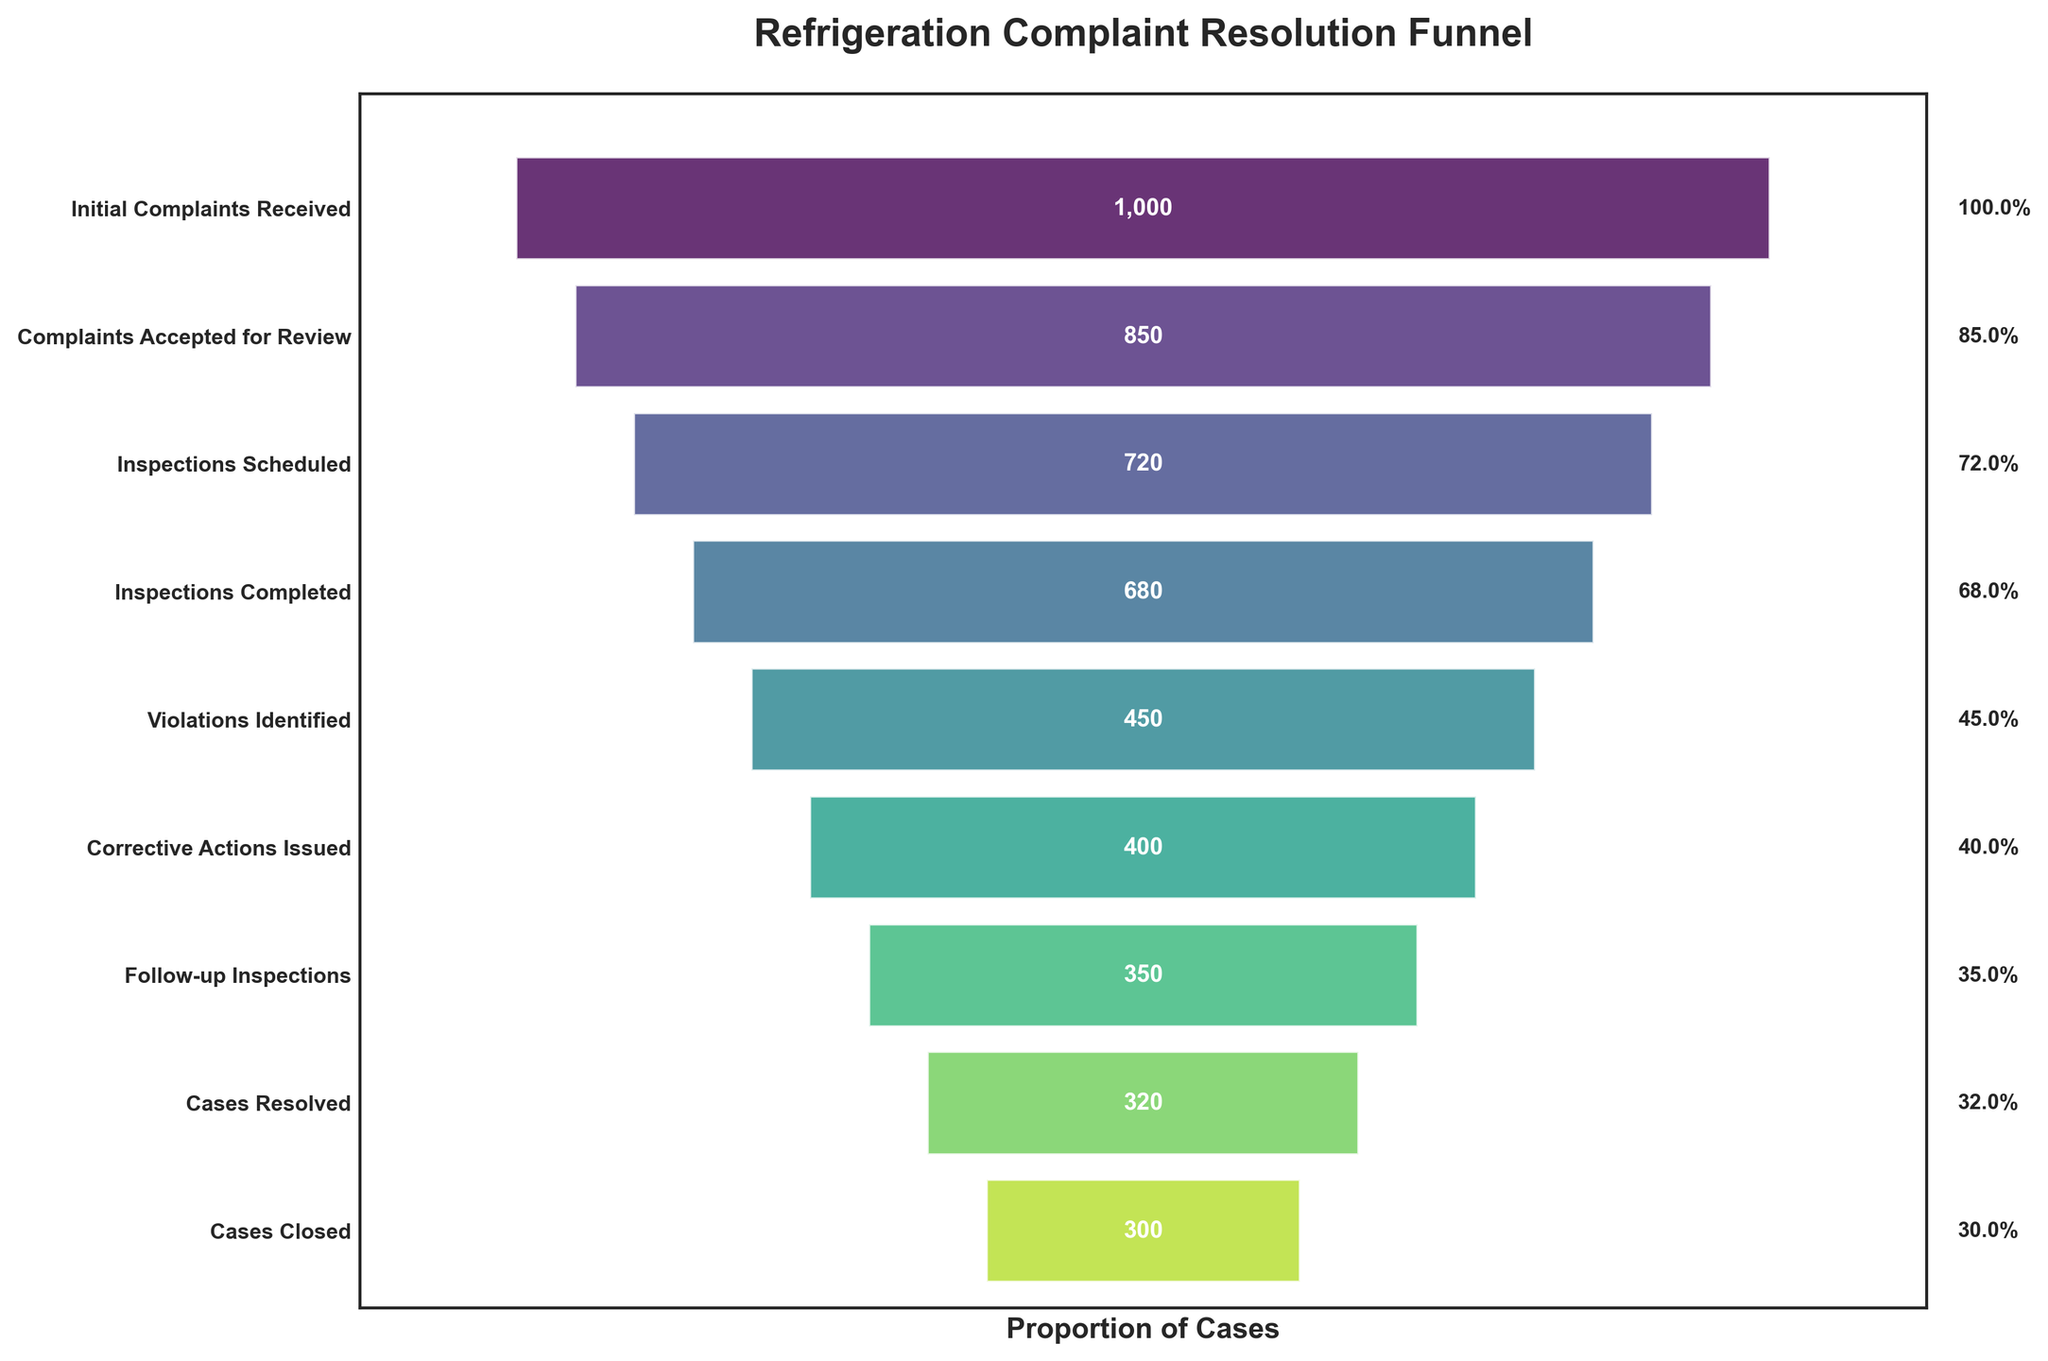What is the title of the chart? The title is usually found at the top of the chart, and it provides a summary of what the chart is about. In this case, it is "Refrigeration Complaint Resolution Funnel" as described in the plotting code.
Answer: Refrigeration Complaint Resolution Funnel How many cases were initially received? Look at the beginning of the funnel where it displays the first stage. The number next to "Initial Complaints Received" is 1000.
Answer: 1000 What percentage of the initial complaints were accepted for review? Divide the "Complaints Accepted for Review" (850) by the "Initial Complaints Received" (1000) and multiply by 100 to get the percentage: (850/1000) * 100 = 85%.
Answer: 85% How many steps are between "Inspections Completed" and "Cases Closed"? Count the number of stages starting from "Inspections Completed" to "Cases Closed." These are "Violations Identified,” "Corrective Actions Issued,” "Follow-up Inspections,” "Cases Resolved,” and "Cases Closed,” making it a total of 5 steps.
Answer: 5 By how much did the number of cases drop from "Violations Identified" to "Corrective Actions Issued"? Subtract the number of "Corrective Actions Issued" (400) from "Violations Identified" (450). The drop is 450 - 400 = 50.
Answer: 50 What stage has the smallest number of cases? Look for the stage with the smallest numeric value listed. This would be the "Cases Closed" stage, which has 300 cases.
Answer: Cases Closed What is the difference in case numbers between the "Follow-up Inspections" and the "Cases Closed" stages? Subtract the number of "Cases Closed" (300) from "Follow-up Inspections" (350). The difference is 350 - 300 = 50.
Answer: 50 What percentage of cases proceeded to follow-up inspections after corrective actions were issued? Divide the "Follow-up Inspections" (350) by the "Corrective Actions Issued" (400) and multiply by 100 to get the percentage: (350/400) * 100 = 87.5%.
Answer: 87.5% How many more cases are resolved than closed? Subtract the number of "Cases Closed" (300) from "Cases Resolved" (320). The difference is 320 - 300 = 20.
Answer: 20 